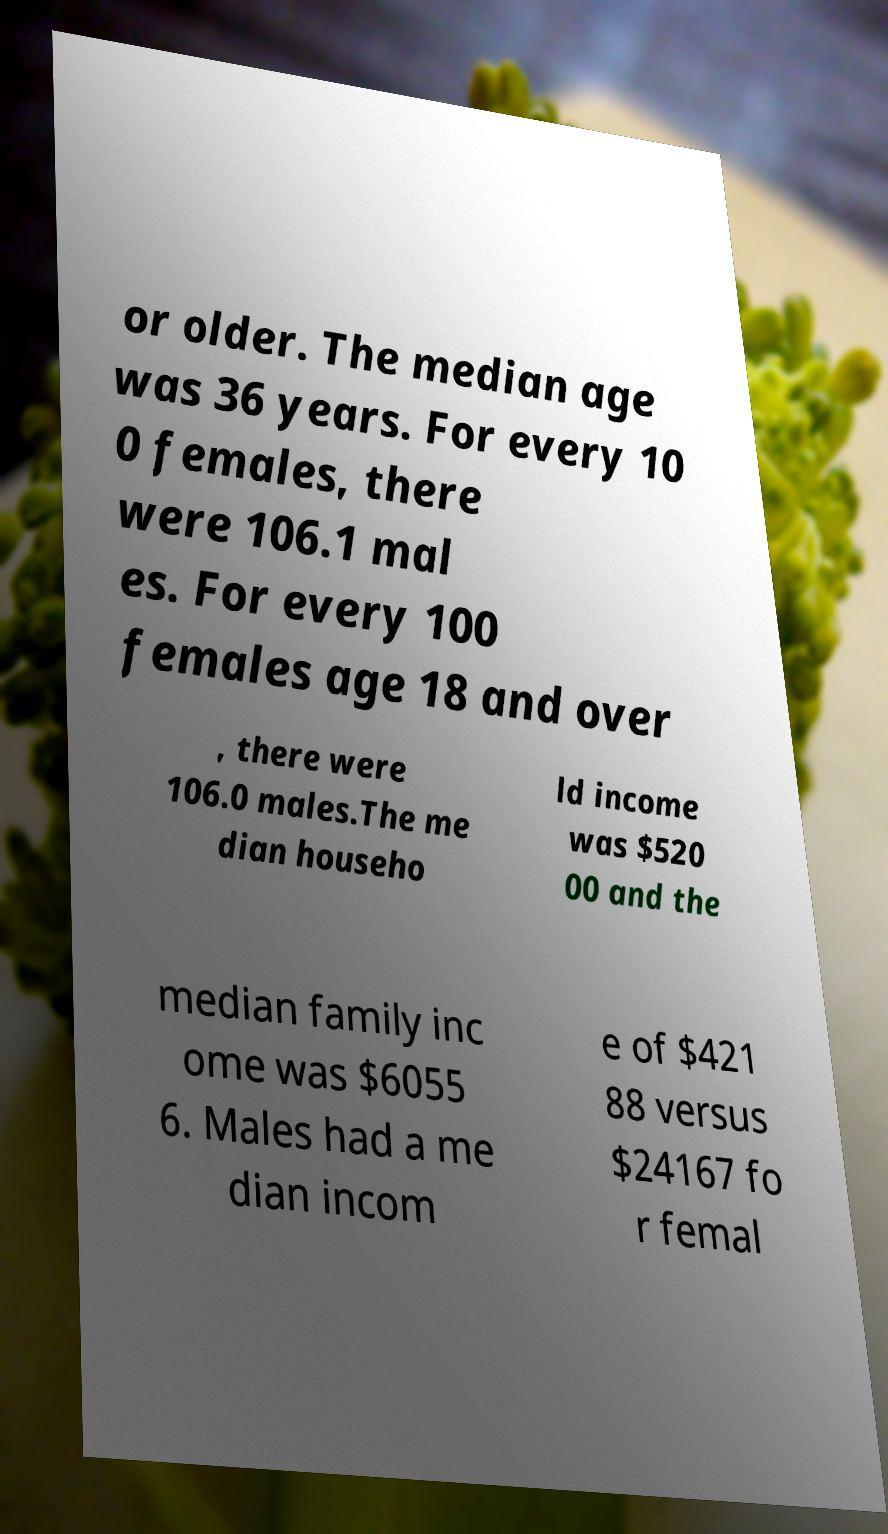Please read and relay the text visible in this image. What does it say? or older. The median age was 36 years. For every 10 0 females, there were 106.1 mal es. For every 100 females age 18 and over , there were 106.0 males.The me dian househo ld income was $520 00 and the median family inc ome was $6055 6. Males had a me dian incom e of $421 88 versus $24167 fo r femal 